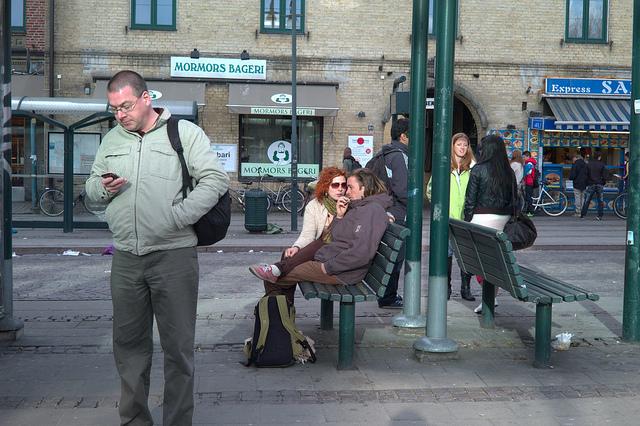Is the paint fresh on the poles?
Give a very brief answer. No. What are on the men's heads?
Keep it brief. Hair. What is sold at the bageri?
Be succinct. Bagels. Are the signs in English?
Be succinct. No. What does it say on the store window?
Be succinct. Mormors bageri. How many people are sitting?
Quick response, please. 2. How many women are sitting down?
Write a very short answer. 2. Are they in a parade?
Give a very brief answer. No. What is made of metal?
Give a very brief answer. Poles. 